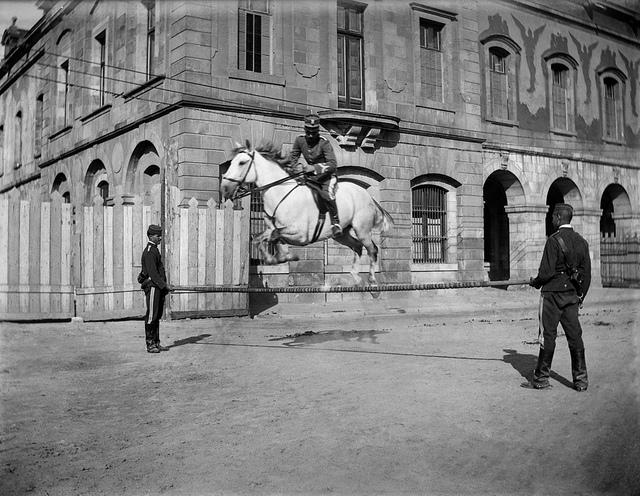Is this man dressed professionally?
Be succinct. Yes. Is this animal flying?
Keep it brief. No. Are the men waiting for a train?
Quick response, please. No. How many people are in this picture?
Short answer required. 3. Is he walking under an arch?
Write a very short answer. No. Are these men in the military?
Write a very short answer. Yes. 